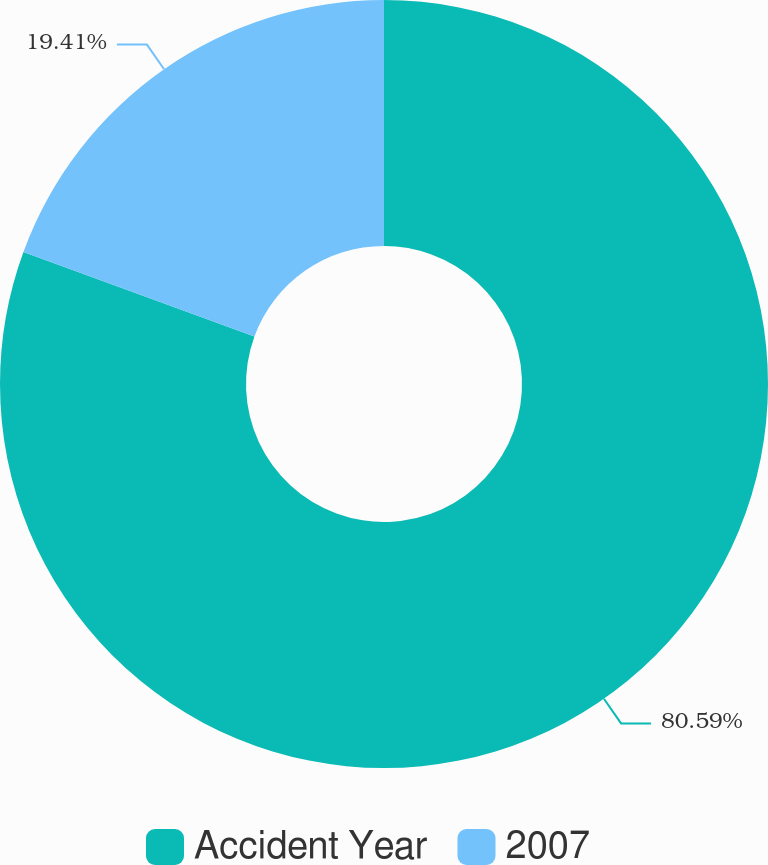Convert chart. <chart><loc_0><loc_0><loc_500><loc_500><pie_chart><fcel>Accident Year<fcel>2007<nl><fcel>80.59%<fcel>19.41%<nl></chart> 